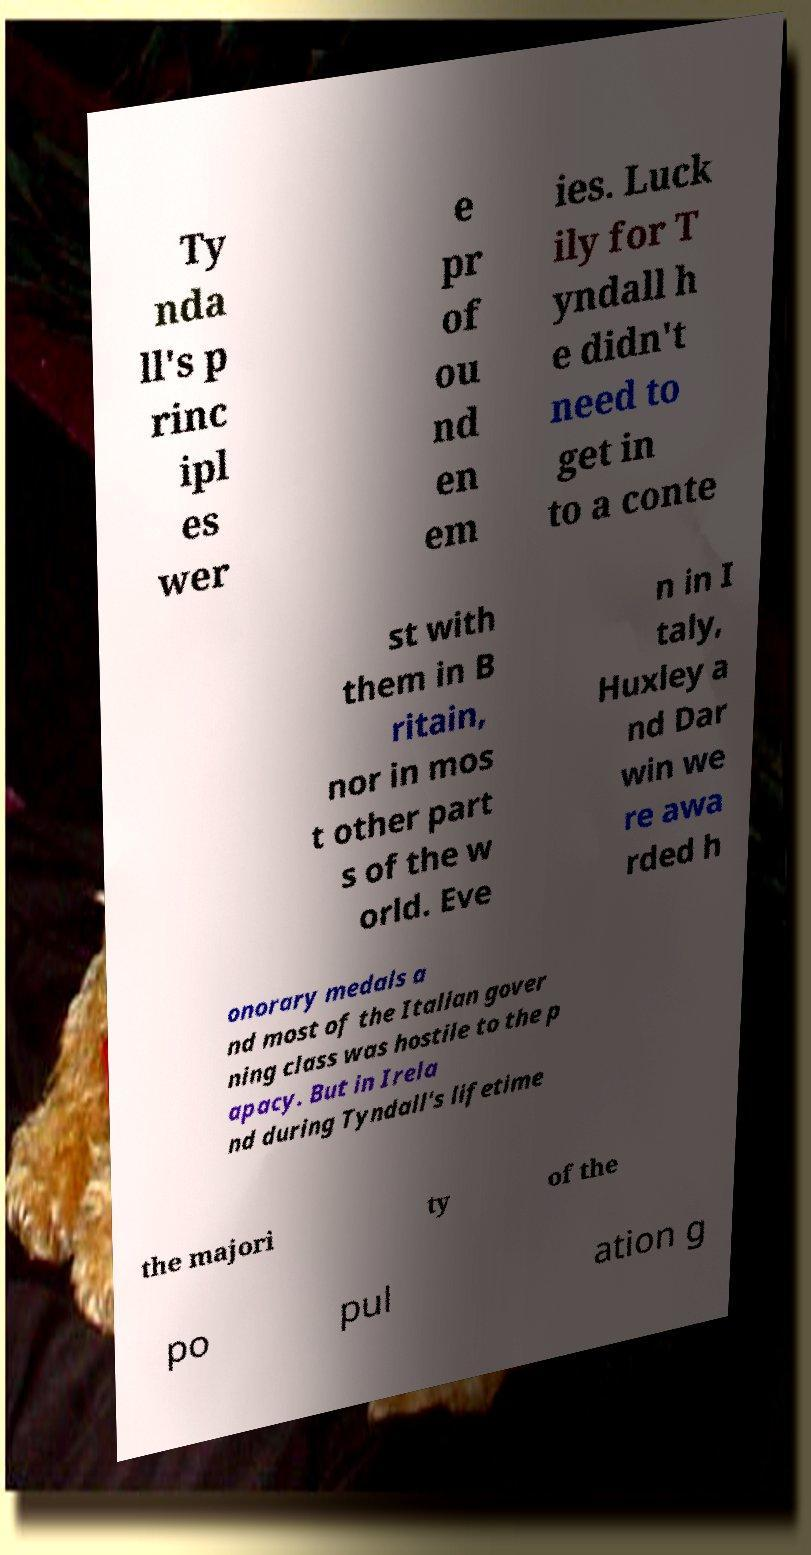I need the written content from this picture converted into text. Can you do that? Ty nda ll's p rinc ipl es wer e pr of ou nd en em ies. Luck ily for T yndall h e didn't need to get in to a conte st with them in B ritain, nor in mos t other part s of the w orld. Eve n in I taly, Huxley a nd Dar win we re awa rded h onorary medals a nd most of the Italian gover ning class was hostile to the p apacy. But in Irela nd during Tyndall's lifetime the majori ty of the po pul ation g 